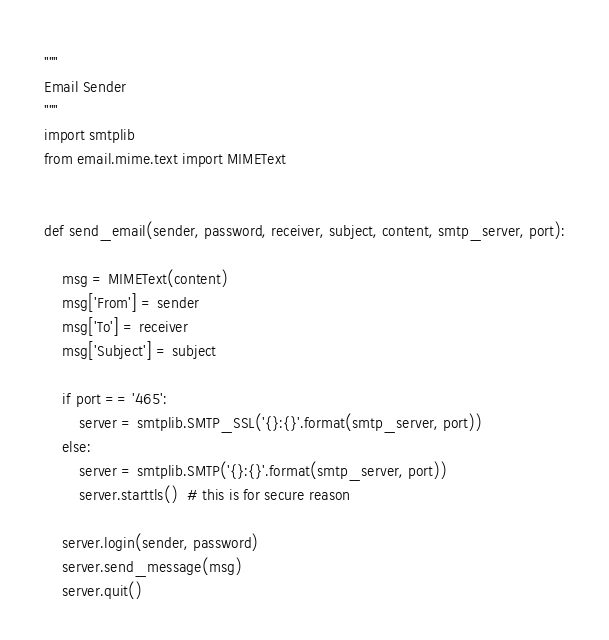<code> <loc_0><loc_0><loc_500><loc_500><_Python_>"""
Email Sender
"""
import smtplib
from email.mime.text import MIMEText


def send_email(sender, password, receiver, subject, content, smtp_server, port):

    msg = MIMEText(content)
    msg['From'] = sender
    msg['To'] = receiver
    msg['Subject'] = subject

    if port == '465':
        server = smtplib.SMTP_SSL('{}:{}'.format(smtp_server, port))
    else:
        server = smtplib.SMTP('{}:{}'.format(smtp_server, port))
        server.starttls()  # this is for secure reason

    server.login(sender, password)
    server.send_message(msg)
    server.quit()
</code> 